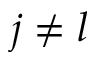<formula> <loc_0><loc_0><loc_500><loc_500>j \neq l</formula> 